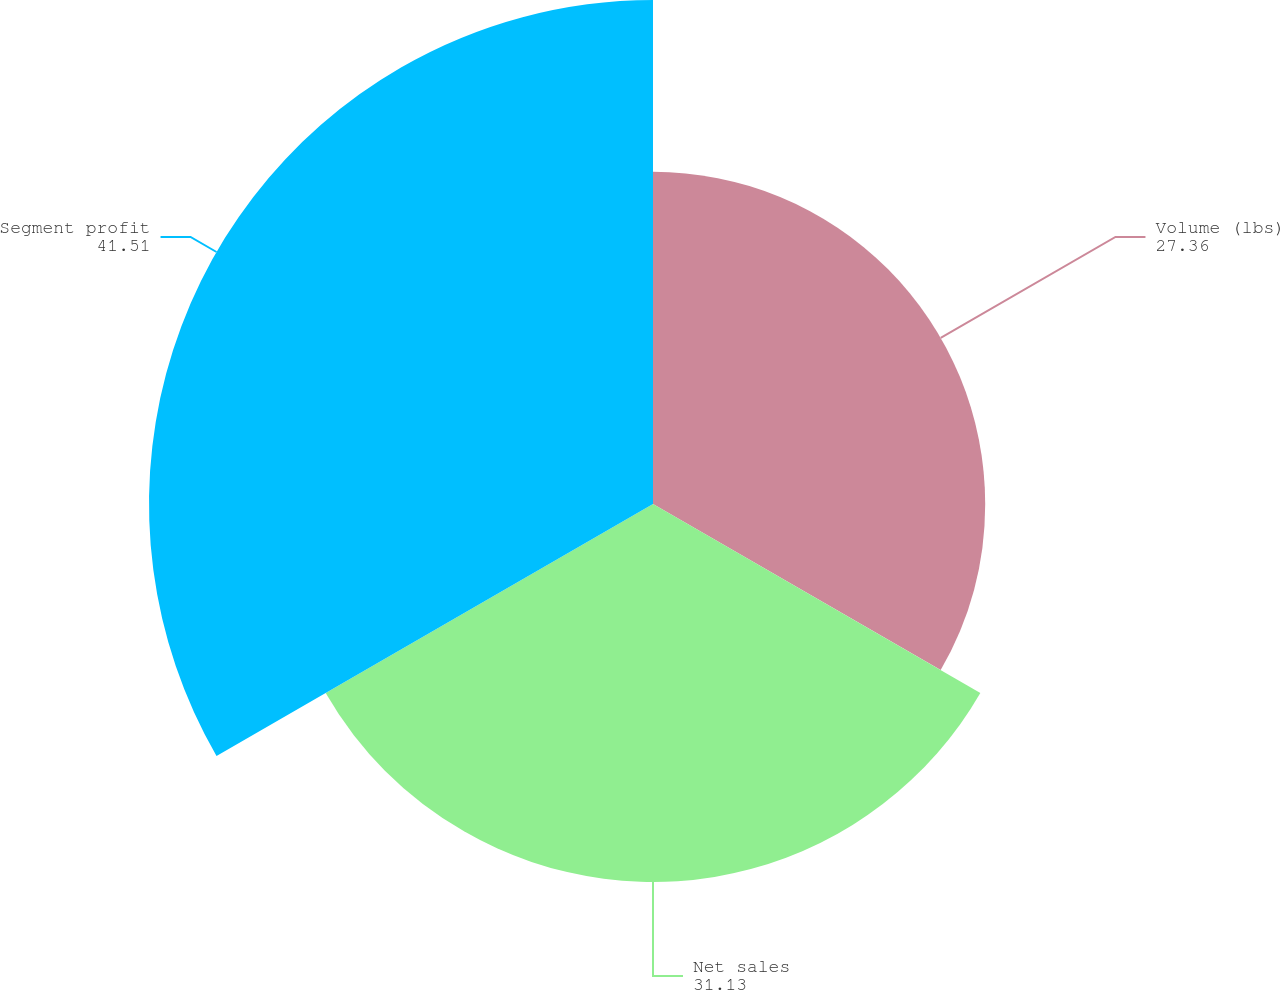Convert chart. <chart><loc_0><loc_0><loc_500><loc_500><pie_chart><fcel>Volume (lbs)<fcel>Net sales<fcel>Segment profit<nl><fcel>27.36%<fcel>31.13%<fcel>41.51%<nl></chart> 